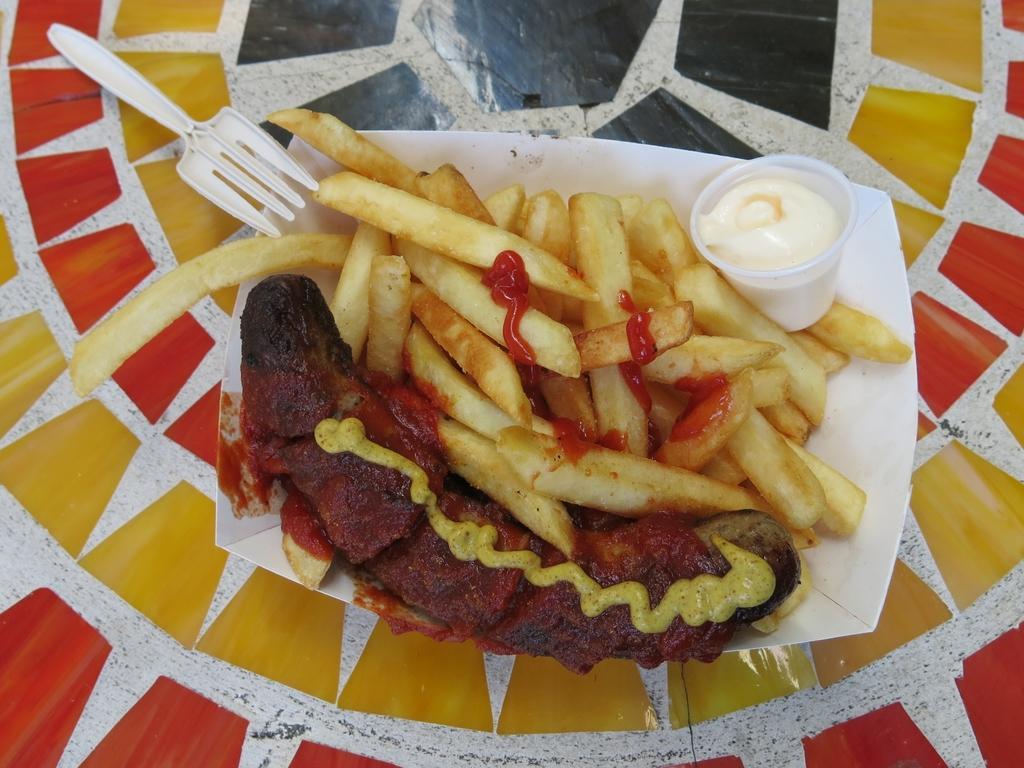Can you describe this image briefly? As we can see in the image there is a fork, glass, french fries and hotdog. 